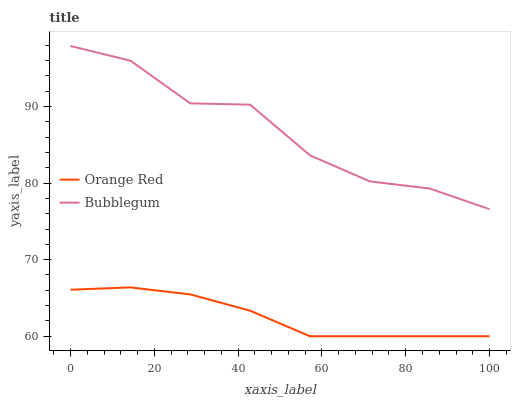Does Orange Red have the minimum area under the curve?
Answer yes or no. Yes. Does Bubblegum have the maximum area under the curve?
Answer yes or no. Yes. Does Bubblegum have the minimum area under the curve?
Answer yes or no. No. Is Orange Red the smoothest?
Answer yes or no. Yes. Is Bubblegum the roughest?
Answer yes or no. Yes. Is Bubblegum the smoothest?
Answer yes or no. No. Does Orange Red have the lowest value?
Answer yes or no. Yes. Does Bubblegum have the lowest value?
Answer yes or no. No. Does Bubblegum have the highest value?
Answer yes or no. Yes. Is Orange Red less than Bubblegum?
Answer yes or no. Yes. Is Bubblegum greater than Orange Red?
Answer yes or no. Yes. Does Orange Red intersect Bubblegum?
Answer yes or no. No. 